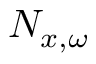<formula> <loc_0><loc_0><loc_500><loc_500>N _ { x , \omega }</formula> 